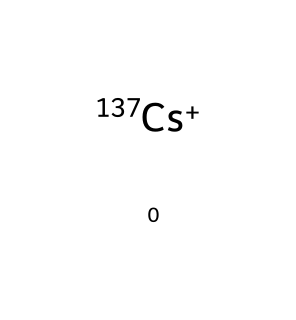What is the atomic symbol for this isotope? The chemical representation shows cesium with a nuclear notation for its isotope, which is indicated by the symbol "Cs" followed by its mass number "137".
Answer: Cs How many protons does cesium-137 have? The atomic number of cesium (Cs) is 55, indicating it has 55 protons regardless of the isotope.
Answer: 55 Is cesium-137 radioactive? The SMILES notation specifies that it is cesium-137, a well-known radioactive isotope, indicating it undergoes radioactive decay.
Answer: Yes What is the primary decay product of cesium-137? Cesium-137 primarily decays into barium-137m, which is a metastable isotope of barium, also indicated in relevant decay chains.
Answer: Barium-137m How does cesium-137 affect marine ecosystems? The presence of cesium-137 in marine environments can lead to bioaccumulation in marine organisms, potentially disrupting food chains and causing health issues.
Answer: Disruption What type of ion is represented by cesium-137? The notation "[137Cs+]" specifies that csium-137 exists as a positively charged ion, known as a cation, in this context.
Answer: Cation What is the significance of cesium-137 in nuclear waste? Cesium-137 is a long-lived isotope found in nuclear waste, which poses risks due to its radiotoxicity and ability to contaminate water sources.
Answer: Radiotoxicity 